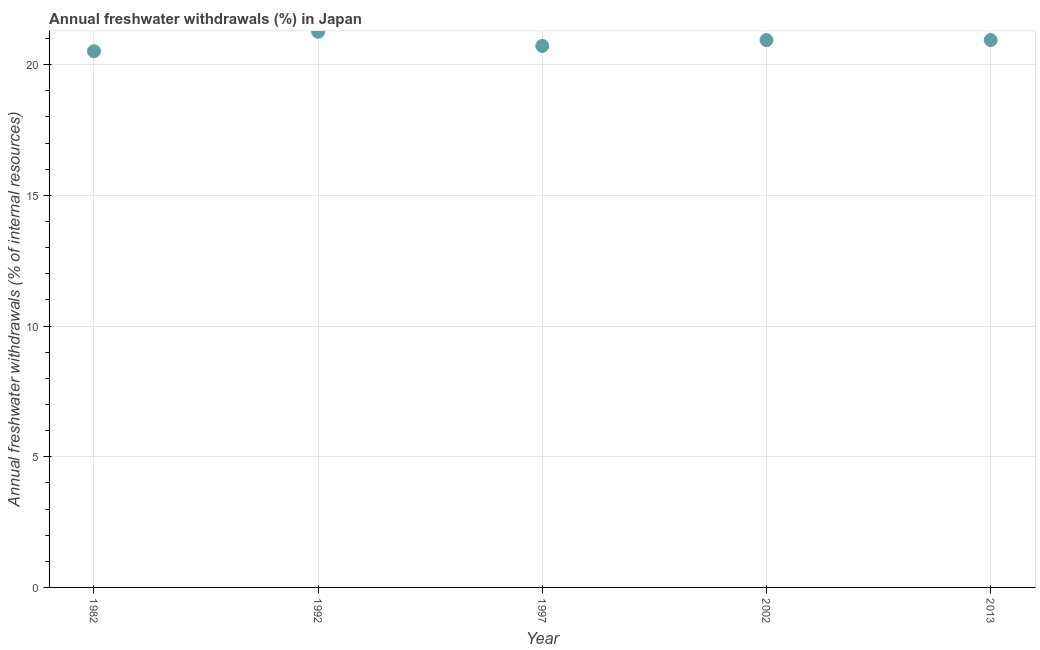What is the annual freshwater withdrawals in 1982?
Offer a terse response. 20.51. Across all years, what is the maximum annual freshwater withdrawals?
Ensure brevity in your answer.  21.26. Across all years, what is the minimum annual freshwater withdrawals?
Offer a very short reply. 20.51. In which year was the annual freshwater withdrawals maximum?
Your answer should be compact. 1992. What is the sum of the annual freshwater withdrawals?
Your answer should be compact. 104.36. What is the difference between the annual freshwater withdrawals in 1982 and 1992?
Offer a terse response. -0.74. What is the average annual freshwater withdrawals per year?
Your answer should be very brief. 20.87. What is the median annual freshwater withdrawals?
Provide a succinct answer. 20.94. In how many years, is the annual freshwater withdrawals greater than 17 %?
Provide a succinct answer. 5. What is the ratio of the annual freshwater withdrawals in 1992 to that in 2013?
Ensure brevity in your answer.  1.02. Is the difference between the annual freshwater withdrawals in 1982 and 2002 greater than the difference between any two years?
Offer a very short reply. No. What is the difference between the highest and the second highest annual freshwater withdrawals?
Your answer should be compact. 0.32. Is the sum of the annual freshwater withdrawals in 1997 and 2002 greater than the maximum annual freshwater withdrawals across all years?
Keep it short and to the point. Yes. What is the difference between the highest and the lowest annual freshwater withdrawals?
Ensure brevity in your answer.  0.74. Does the annual freshwater withdrawals monotonically increase over the years?
Ensure brevity in your answer.  No. How many years are there in the graph?
Ensure brevity in your answer.  5. Are the values on the major ticks of Y-axis written in scientific E-notation?
Offer a very short reply. No. Does the graph contain grids?
Offer a very short reply. Yes. What is the title of the graph?
Your answer should be very brief. Annual freshwater withdrawals (%) in Japan. What is the label or title of the X-axis?
Give a very brief answer. Year. What is the label or title of the Y-axis?
Ensure brevity in your answer.  Annual freshwater withdrawals (% of internal resources). What is the Annual freshwater withdrawals (% of internal resources) in 1982?
Your response must be concise. 20.51. What is the Annual freshwater withdrawals (% of internal resources) in 1992?
Your response must be concise. 21.26. What is the Annual freshwater withdrawals (% of internal resources) in 1997?
Make the answer very short. 20.71. What is the Annual freshwater withdrawals (% of internal resources) in 2002?
Your response must be concise. 20.94. What is the Annual freshwater withdrawals (% of internal resources) in 2013?
Provide a succinct answer. 20.94. What is the difference between the Annual freshwater withdrawals (% of internal resources) in 1982 and 1992?
Provide a succinct answer. -0.74. What is the difference between the Annual freshwater withdrawals (% of internal resources) in 1982 and 1997?
Offer a very short reply. -0.2. What is the difference between the Annual freshwater withdrawals (% of internal resources) in 1982 and 2002?
Keep it short and to the point. -0.43. What is the difference between the Annual freshwater withdrawals (% of internal resources) in 1982 and 2013?
Your answer should be compact. -0.43. What is the difference between the Annual freshwater withdrawals (% of internal resources) in 1992 and 1997?
Your answer should be compact. 0.54. What is the difference between the Annual freshwater withdrawals (% of internal resources) in 1992 and 2002?
Offer a terse response. 0.32. What is the difference between the Annual freshwater withdrawals (% of internal resources) in 1992 and 2013?
Provide a short and direct response. 0.32. What is the difference between the Annual freshwater withdrawals (% of internal resources) in 1997 and 2002?
Your answer should be very brief. -0.23. What is the difference between the Annual freshwater withdrawals (% of internal resources) in 1997 and 2013?
Keep it short and to the point. -0.23. What is the difference between the Annual freshwater withdrawals (% of internal resources) in 2002 and 2013?
Keep it short and to the point. 0. What is the ratio of the Annual freshwater withdrawals (% of internal resources) in 1982 to that in 1997?
Keep it short and to the point. 0.99. What is the ratio of the Annual freshwater withdrawals (% of internal resources) in 1982 to that in 2002?
Give a very brief answer. 0.98. What is the ratio of the Annual freshwater withdrawals (% of internal resources) in 1982 to that in 2013?
Keep it short and to the point. 0.98. What is the ratio of the Annual freshwater withdrawals (% of internal resources) in 1992 to that in 1997?
Ensure brevity in your answer.  1.03. What is the ratio of the Annual freshwater withdrawals (% of internal resources) in 1992 to that in 2002?
Give a very brief answer. 1.01. What is the ratio of the Annual freshwater withdrawals (% of internal resources) in 1997 to that in 2013?
Your response must be concise. 0.99. 